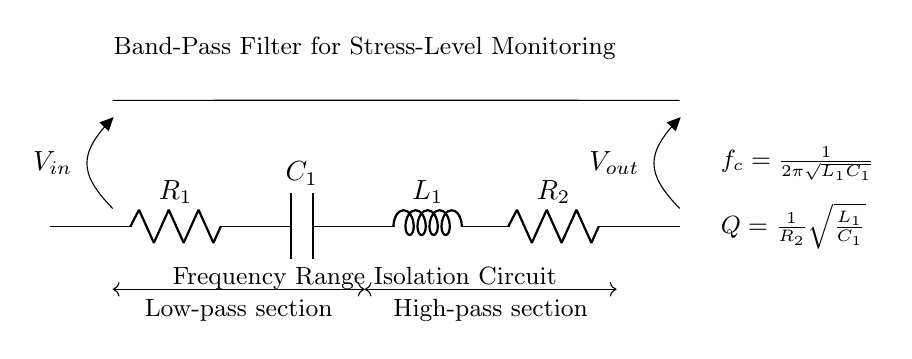What kind of filter is depicted in the diagram? The circuit diagram shows a band-pass filter, which allows a specific range of frequencies to pass through while attenuating frequencies outside this range. This is indicated by the labeling and design of the components used in the circuit.
Answer: Band-pass filter What components are used in this circuit? The circuit consists of two resistors, one capacitor, and one inductor. These components are critical in shaping the frequency response of the filter. The specific components identified are R1, R2, C1, and L1.
Answer: Resistors, capacitor, inductor What is the output voltage symbol in the diagram? The output voltage is indicated at the right side of the circuit diagram with the symbol Vout. This shows where the filtered signal can be measured in the circuit.
Answer: Vout What is the cutoff frequency formula used in this circuit? The cutoff frequency formula presented in the diagram is given by fc = 1/(2π√(L1*C1)). This indicates how the cutoff frequency is determined by the values of the inductor and capacitor in the circuit design.
Answer: fc = 1/(2π√(L1*C1)) What effect does R2 have on the quality factor? R2 affects the quality factor (Q) of the filter, defined as Q = 1/R2√(L1/C1). A smaller R2 increases Q, leading to a narrower bandwidth, thus allowing for better frequency isolation. This relationship emphasizes its role in the performance of the band-pass filter.
Answer: Q = 1/R2√(L1/C1) What sections are present in this band-pass filter circuit? There are two distinct sections in the band-pass filter: the low-pass section and the high-pass section. The low-pass section is from R1 to C1, and the high-pass section is from L1 to R2, indicating how the circuit allows frequencies to pass at certain ranges.
Answer: Low-pass section, high-pass section What is the significance of the frequency range isolation? The circuit is designed to isolate a specific range of frequencies, which is significant for monitoring stress levels in devices. By filtering out irrelevant frequency noise, the circuit helps in accurately measuring stress-related signals in students or individuals in a study.
Answer: Frequency range isolation 